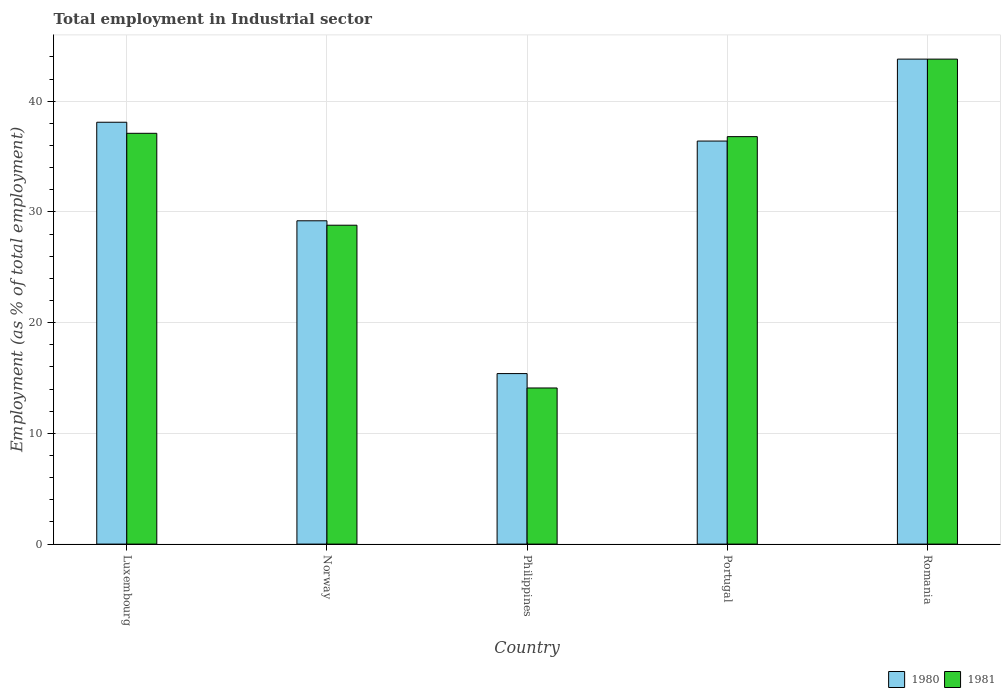How many different coloured bars are there?
Your answer should be very brief. 2. Are the number of bars per tick equal to the number of legend labels?
Offer a very short reply. Yes. Are the number of bars on each tick of the X-axis equal?
Give a very brief answer. Yes. How many bars are there on the 1st tick from the right?
Give a very brief answer. 2. What is the label of the 1st group of bars from the left?
Provide a succinct answer. Luxembourg. In how many cases, is the number of bars for a given country not equal to the number of legend labels?
Keep it short and to the point. 0. What is the employment in industrial sector in 1980 in Philippines?
Offer a terse response. 15.4. Across all countries, what is the maximum employment in industrial sector in 1981?
Keep it short and to the point. 43.8. Across all countries, what is the minimum employment in industrial sector in 1981?
Give a very brief answer. 14.1. In which country was the employment in industrial sector in 1981 maximum?
Ensure brevity in your answer.  Romania. What is the total employment in industrial sector in 1980 in the graph?
Your answer should be very brief. 162.9. What is the difference between the employment in industrial sector in 1980 in Luxembourg and that in Philippines?
Give a very brief answer. 22.7. What is the difference between the employment in industrial sector in 1980 in Norway and the employment in industrial sector in 1981 in Romania?
Keep it short and to the point. -14.6. What is the average employment in industrial sector in 1981 per country?
Provide a short and direct response. 32.12. What is the difference between the employment in industrial sector of/in 1981 and employment in industrial sector of/in 1980 in Norway?
Provide a short and direct response. -0.4. In how many countries, is the employment in industrial sector in 1980 greater than 20 %?
Make the answer very short. 4. What is the ratio of the employment in industrial sector in 1980 in Luxembourg to that in Portugal?
Your response must be concise. 1.05. What is the difference between the highest and the second highest employment in industrial sector in 1980?
Ensure brevity in your answer.  7.4. What is the difference between the highest and the lowest employment in industrial sector in 1981?
Provide a short and direct response. 29.7. Is the sum of the employment in industrial sector in 1981 in Norway and Portugal greater than the maximum employment in industrial sector in 1980 across all countries?
Offer a very short reply. Yes. What does the 2nd bar from the left in Norway represents?
Your response must be concise. 1981. What is the difference between two consecutive major ticks on the Y-axis?
Provide a succinct answer. 10. Does the graph contain any zero values?
Your answer should be compact. No. Where does the legend appear in the graph?
Provide a short and direct response. Bottom right. How many legend labels are there?
Give a very brief answer. 2. How are the legend labels stacked?
Offer a very short reply. Horizontal. What is the title of the graph?
Your answer should be compact. Total employment in Industrial sector. What is the label or title of the X-axis?
Provide a short and direct response. Country. What is the label or title of the Y-axis?
Provide a succinct answer. Employment (as % of total employment). What is the Employment (as % of total employment) of 1980 in Luxembourg?
Provide a succinct answer. 38.1. What is the Employment (as % of total employment) in 1981 in Luxembourg?
Your answer should be compact. 37.1. What is the Employment (as % of total employment) of 1980 in Norway?
Keep it short and to the point. 29.2. What is the Employment (as % of total employment) of 1981 in Norway?
Your response must be concise. 28.8. What is the Employment (as % of total employment) of 1980 in Philippines?
Give a very brief answer. 15.4. What is the Employment (as % of total employment) of 1981 in Philippines?
Your answer should be compact. 14.1. What is the Employment (as % of total employment) of 1980 in Portugal?
Your answer should be compact. 36.4. What is the Employment (as % of total employment) of 1981 in Portugal?
Provide a succinct answer. 36.8. What is the Employment (as % of total employment) in 1980 in Romania?
Your response must be concise. 43.8. What is the Employment (as % of total employment) of 1981 in Romania?
Your answer should be very brief. 43.8. Across all countries, what is the maximum Employment (as % of total employment) in 1980?
Your response must be concise. 43.8. Across all countries, what is the maximum Employment (as % of total employment) in 1981?
Offer a very short reply. 43.8. Across all countries, what is the minimum Employment (as % of total employment) in 1980?
Keep it short and to the point. 15.4. Across all countries, what is the minimum Employment (as % of total employment) in 1981?
Your response must be concise. 14.1. What is the total Employment (as % of total employment) of 1980 in the graph?
Your answer should be compact. 162.9. What is the total Employment (as % of total employment) of 1981 in the graph?
Your answer should be compact. 160.6. What is the difference between the Employment (as % of total employment) in 1981 in Luxembourg and that in Norway?
Offer a terse response. 8.3. What is the difference between the Employment (as % of total employment) in 1980 in Luxembourg and that in Philippines?
Your response must be concise. 22.7. What is the difference between the Employment (as % of total employment) of 1981 in Luxembourg and that in Portugal?
Ensure brevity in your answer.  0.3. What is the difference between the Employment (as % of total employment) in 1980 in Norway and that in Portugal?
Offer a terse response. -7.2. What is the difference between the Employment (as % of total employment) of 1981 in Norway and that in Portugal?
Make the answer very short. -8. What is the difference between the Employment (as % of total employment) of 1980 in Norway and that in Romania?
Offer a terse response. -14.6. What is the difference between the Employment (as % of total employment) of 1980 in Philippines and that in Portugal?
Your answer should be compact. -21. What is the difference between the Employment (as % of total employment) of 1981 in Philippines and that in Portugal?
Offer a very short reply. -22.7. What is the difference between the Employment (as % of total employment) of 1980 in Philippines and that in Romania?
Keep it short and to the point. -28.4. What is the difference between the Employment (as % of total employment) in 1981 in Philippines and that in Romania?
Your answer should be very brief. -29.7. What is the difference between the Employment (as % of total employment) of 1980 in Portugal and that in Romania?
Offer a very short reply. -7.4. What is the difference between the Employment (as % of total employment) in 1980 in Luxembourg and the Employment (as % of total employment) in 1981 in Romania?
Offer a terse response. -5.7. What is the difference between the Employment (as % of total employment) in 1980 in Norway and the Employment (as % of total employment) in 1981 in Portugal?
Offer a terse response. -7.6. What is the difference between the Employment (as % of total employment) of 1980 in Norway and the Employment (as % of total employment) of 1981 in Romania?
Provide a short and direct response. -14.6. What is the difference between the Employment (as % of total employment) in 1980 in Philippines and the Employment (as % of total employment) in 1981 in Portugal?
Offer a terse response. -21.4. What is the difference between the Employment (as % of total employment) of 1980 in Philippines and the Employment (as % of total employment) of 1981 in Romania?
Your answer should be compact. -28.4. What is the difference between the Employment (as % of total employment) of 1980 in Portugal and the Employment (as % of total employment) of 1981 in Romania?
Ensure brevity in your answer.  -7.4. What is the average Employment (as % of total employment) in 1980 per country?
Keep it short and to the point. 32.58. What is the average Employment (as % of total employment) in 1981 per country?
Your answer should be compact. 32.12. What is the difference between the Employment (as % of total employment) in 1980 and Employment (as % of total employment) in 1981 in Romania?
Give a very brief answer. 0. What is the ratio of the Employment (as % of total employment) in 1980 in Luxembourg to that in Norway?
Your answer should be very brief. 1.3. What is the ratio of the Employment (as % of total employment) in 1981 in Luxembourg to that in Norway?
Your response must be concise. 1.29. What is the ratio of the Employment (as % of total employment) of 1980 in Luxembourg to that in Philippines?
Offer a terse response. 2.47. What is the ratio of the Employment (as % of total employment) of 1981 in Luxembourg to that in Philippines?
Your response must be concise. 2.63. What is the ratio of the Employment (as % of total employment) of 1980 in Luxembourg to that in Portugal?
Keep it short and to the point. 1.05. What is the ratio of the Employment (as % of total employment) of 1981 in Luxembourg to that in Portugal?
Provide a short and direct response. 1.01. What is the ratio of the Employment (as % of total employment) of 1980 in Luxembourg to that in Romania?
Keep it short and to the point. 0.87. What is the ratio of the Employment (as % of total employment) in 1981 in Luxembourg to that in Romania?
Offer a terse response. 0.85. What is the ratio of the Employment (as % of total employment) of 1980 in Norway to that in Philippines?
Provide a short and direct response. 1.9. What is the ratio of the Employment (as % of total employment) of 1981 in Norway to that in Philippines?
Your response must be concise. 2.04. What is the ratio of the Employment (as % of total employment) of 1980 in Norway to that in Portugal?
Make the answer very short. 0.8. What is the ratio of the Employment (as % of total employment) in 1981 in Norway to that in Portugal?
Your answer should be compact. 0.78. What is the ratio of the Employment (as % of total employment) of 1980 in Norway to that in Romania?
Provide a succinct answer. 0.67. What is the ratio of the Employment (as % of total employment) in 1981 in Norway to that in Romania?
Make the answer very short. 0.66. What is the ratio of the Employment (as % of total employment) of 1980 in Philippines to that in Portugal?
Ensure brevity in your answer.  0.42. What is the ratio of the Employment (as % of total employment) in 1981 in Philippines to that in Portugal?
Offer a very short reply. 0.38. What is the ratio of the Employment (as % of total employment) of 1980 in Philippines to that in Romania?
Provide a succinct answer. 0.35. What is the ratio of the Employment (as % of total employment) of 1981 in Philippines to that in Romania?
Provide a succinct answer. 0.32. What is the ratio of the Employment (as % of total employment) of 1980 in Portugal to that in Romania?
Your answer should be compact. 0.83. What is the ratio of the Employment (as % of total employment) in 1981 in Portugal to that in Romania?
Make the answer very short. 0.84. What is the difference between the highest and the lowest Employment (as % of total employment) of 1980?
Your answer should be compact. 28.4. What is the difference between the highest and the lowest Employment (as % of total employment) of 1981?
Give a very brief answer. 29.7. 